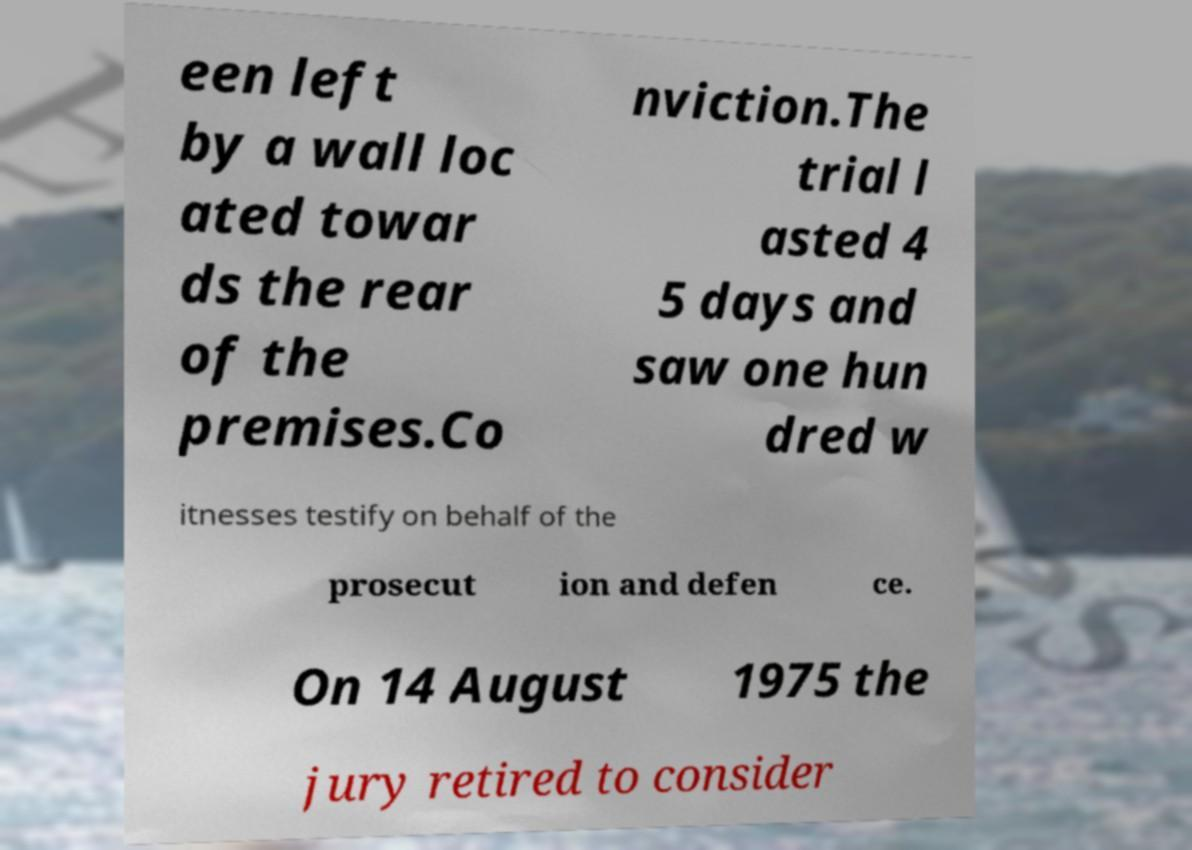What messages or text are displayed in this image? I need them in a readable, typed format. een left by a wall loc ated towar ds the rear of the premises.Co nviction.The trial l asted 4 5 days and saw one hun dred w itnesses testify on behalf of the prosecut ion and defen ce. On 14 August 1975 the jury retired to consider 